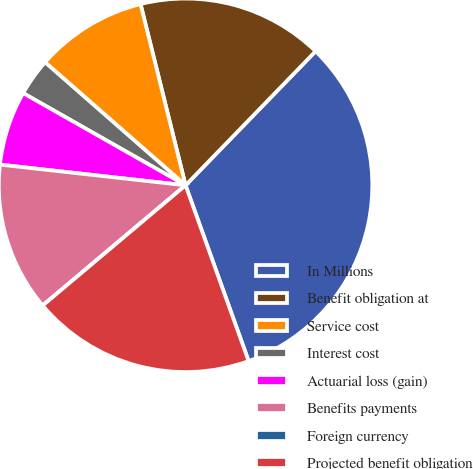Convert chart to OTSL. <chart><loc_0><loc_0><loc_500><loc_500><pie_chart><fcel>In Millions<fcel>Benefit obligation at<fcel>Service cost<fcel>Interest cost<fcel>Actuarial loss (gain)<fcel>Benefits payments<fcel>Foreign currency<fcel>Projected benefit obligation<nl><fcel>32.26%<fcel>16.13%<fcel>9.68%<fcel>3.23%<fcel>6.45%<fcel>12.9%<fcel>0.0%<fcel>19.35%<nl></chart> 